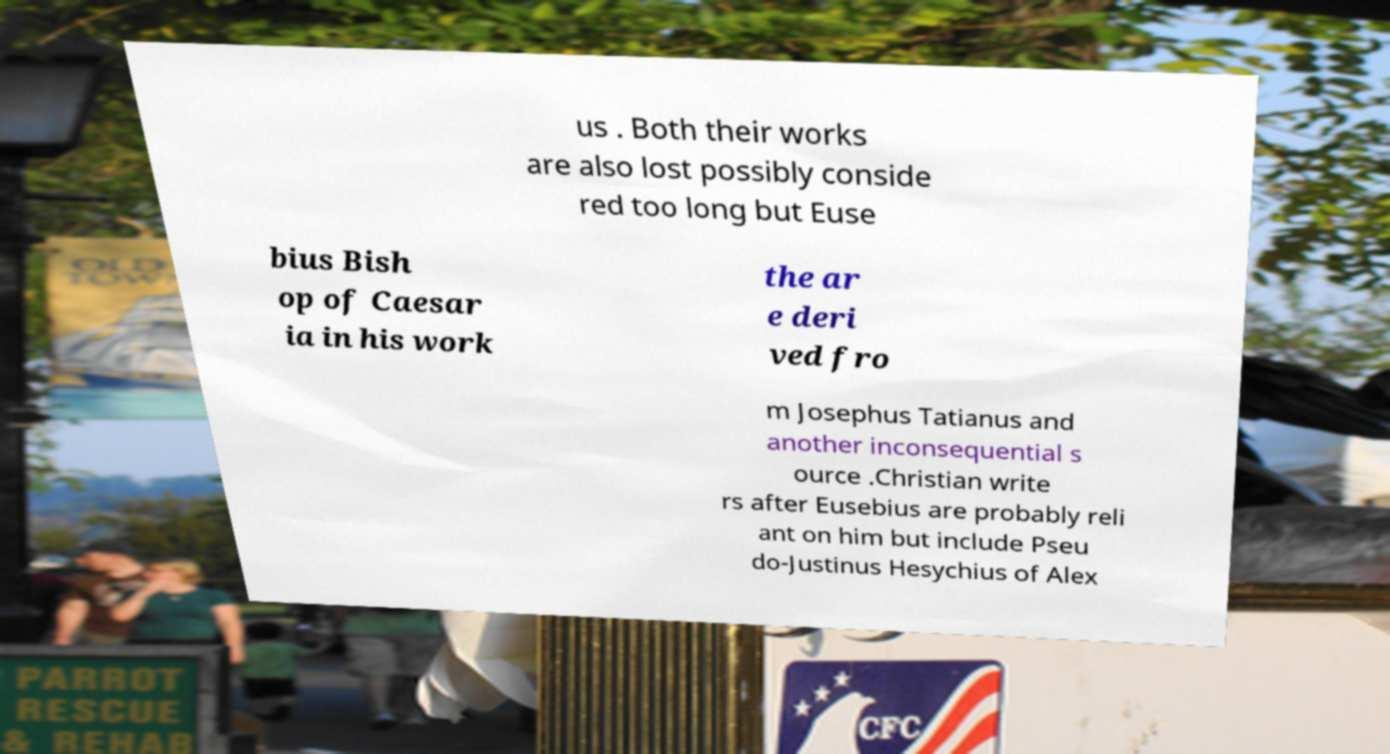Could you assist in decoding the text presented in this image and type it out clearly? us . Both their works are also lost possibly conside red too long but Euse bius Bish op of Caesar ia in his work the ar e deri ved fro m Josephus Tatianus and another inconsequential s ource .Christian write rs after Eusebius are probably reli ant on him but include Pseu do-Justinus Hesychius of Alex 